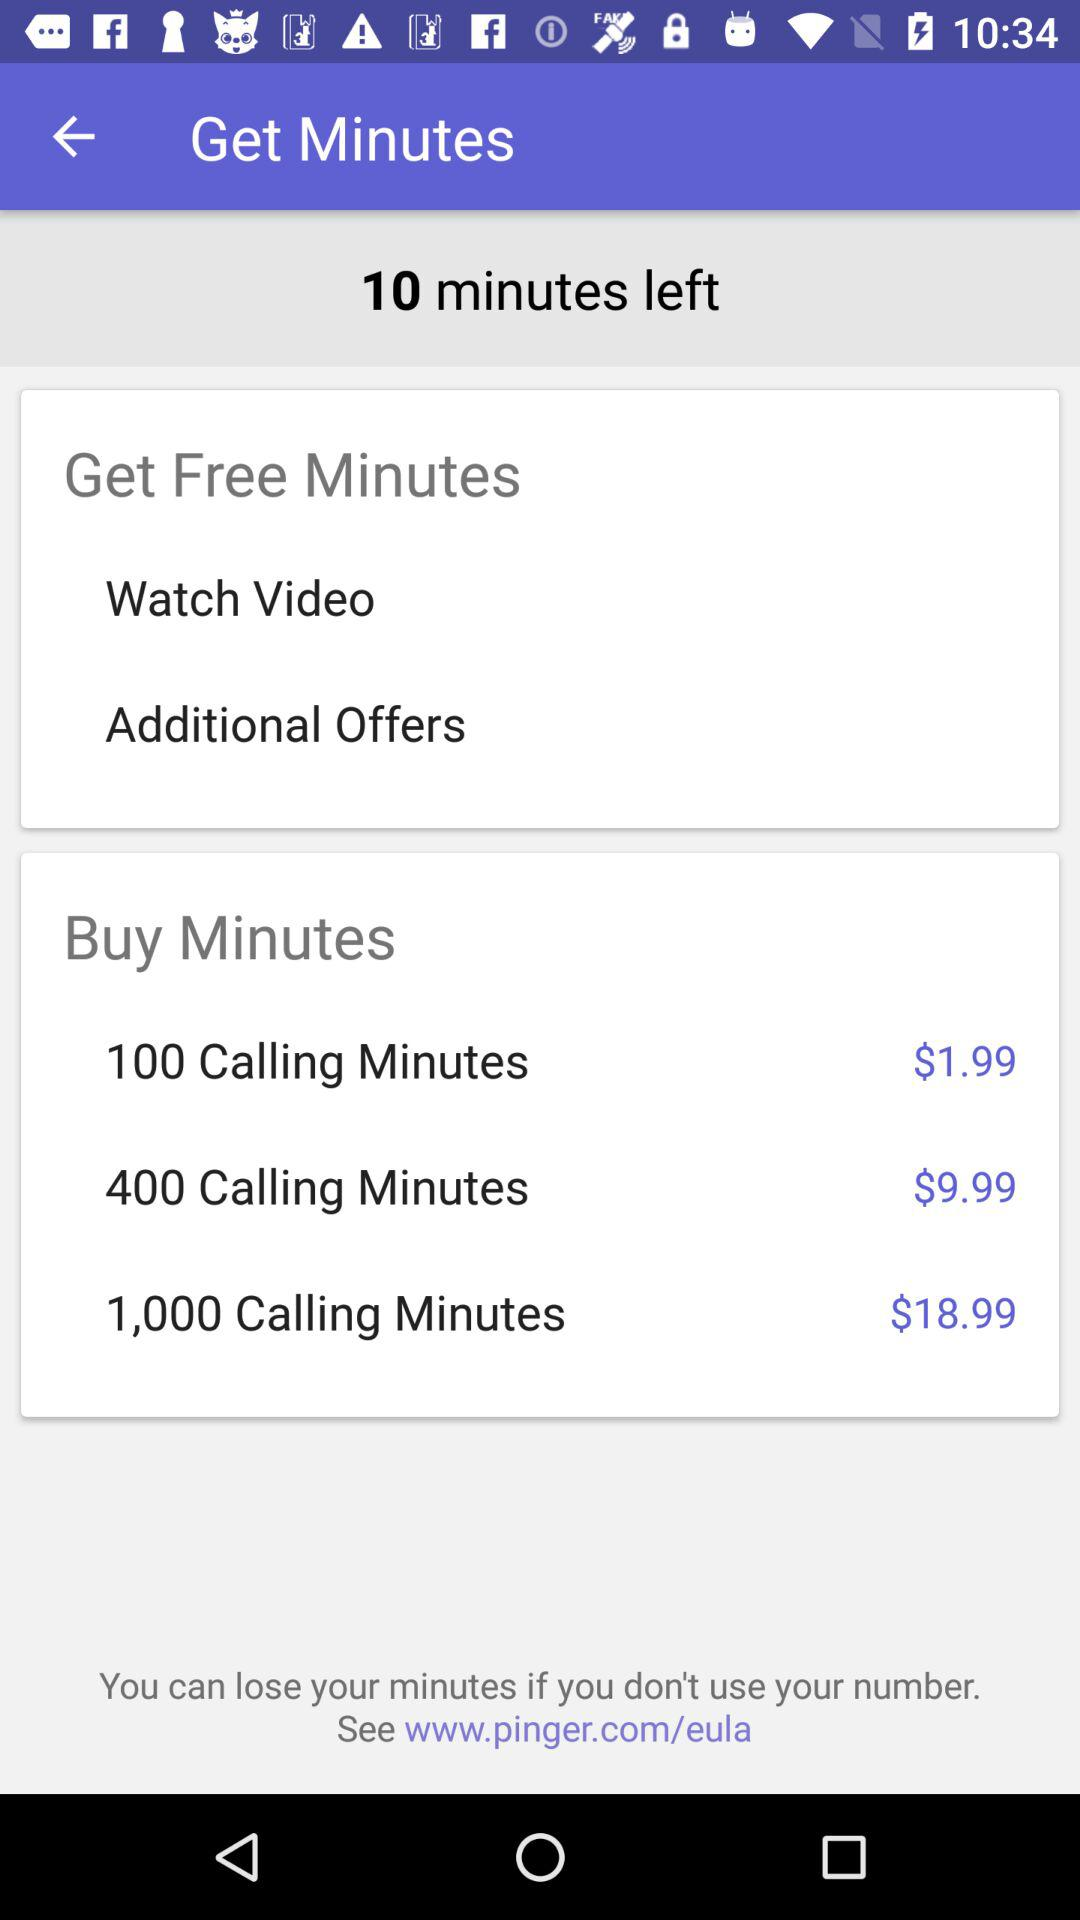How much do I have to pay to buy 400 calling minutes? You have to pay $9.99 to buy 400 calling minutes. 